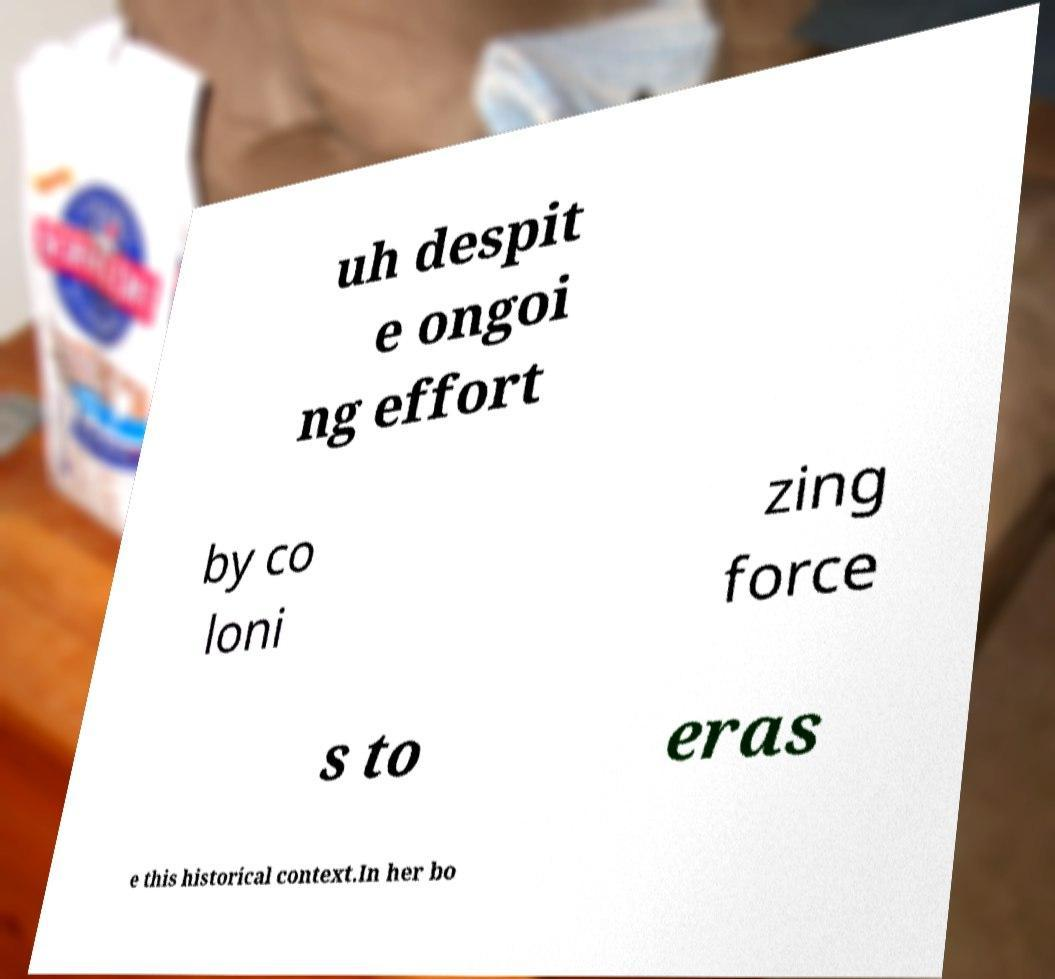Please identify and transcribe the text found in this image. uh despit e ongoi ng effort by co loni zing force s to eras e this historical context.In her bo 